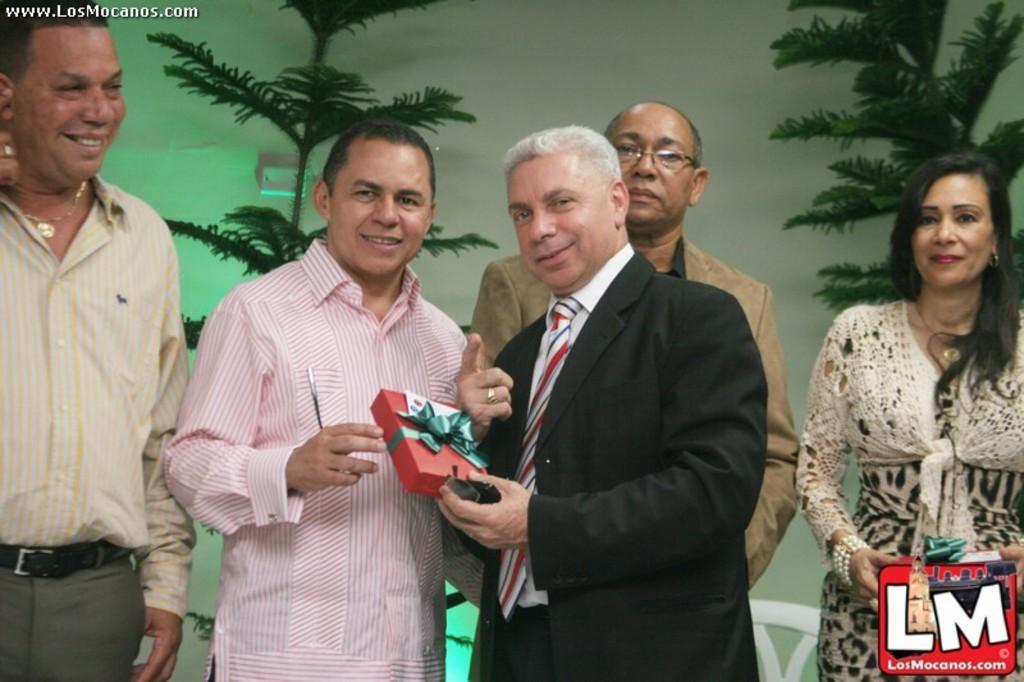In one or two sentences, can you explain what this image depicts? In this image I can see group of people standing, the person standing in front wearing black blazer, white shirt and holding some object which is in red color. Background I can see plants in green color and wall in white color. 